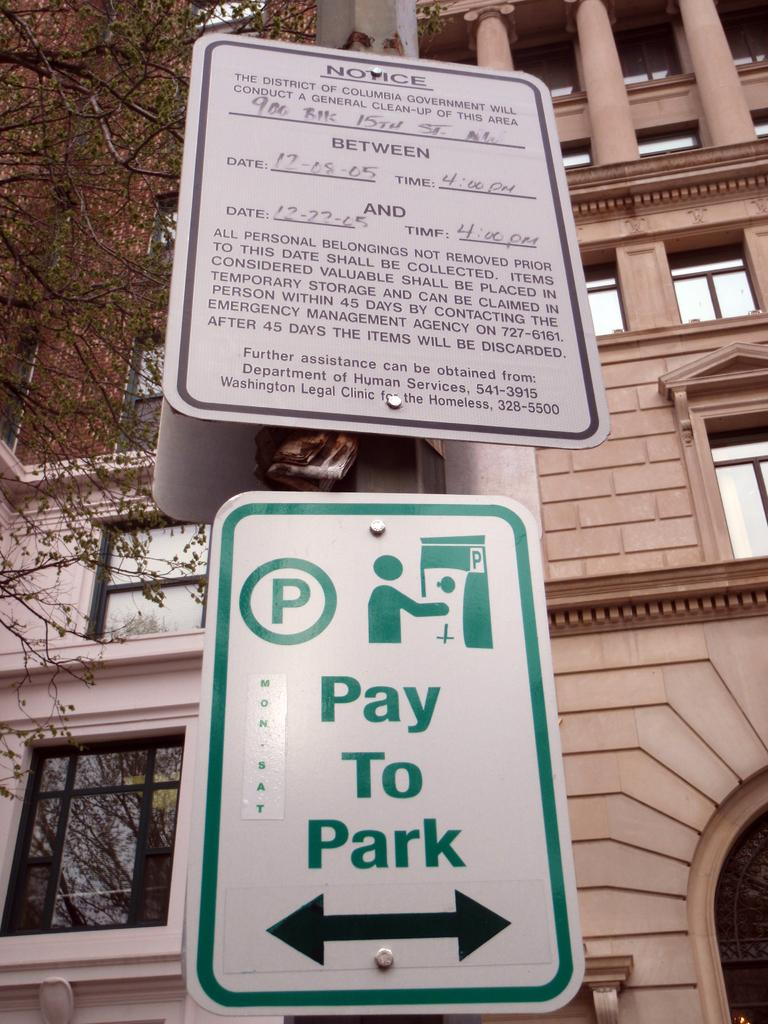<image>
Offer a succinct explanation of the picture presented. One must pay to park on this street in either direction. 